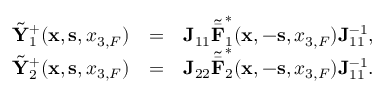Convert formula to latex. <formula><loc_0><loc_0><loc_500><loc_500>\begin{array} { r l r } { \tilde { Y } _ { 1 } ^ { + } ( { x } , { s } , { x _ { 3 , F } } ) } & { = } & { { J } _ { 1 1 } { \tilde { \bar { F } } } _ { 1 } ^ { * } ( { x } , - { s } , { x _ { 3 , F } } ) { J } _ { 1 1 } ^ { - 1 } , } \\ { \tilde { Y } _ { 2 } ^ { + } ( { x } , { s } , { x _ { 3 , F } } ) } & { = } & { { J } _ { 2 2 } { \tilde { \bar { F } } } _ { 2 } ^ { * } ( { x } , - { s } , { x _ { 3 , F } } ) { J } _ { 1 1 } ^ { - 1 } . } \end{array}</formula> 